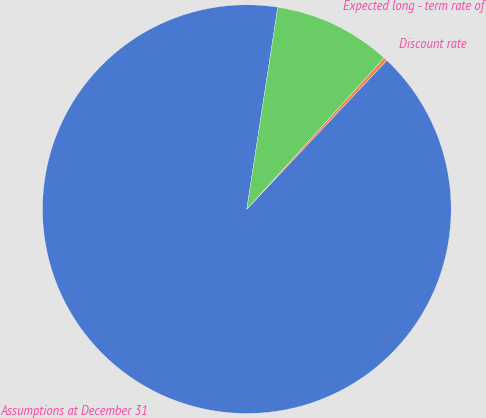Convert chart. <chart><loc_0><loc_0><loc_500><loc_500><pie_chart><fcel>Assumptions at December 31<fcel>Discount rate<fcel>Expected long - term rate of<nl><fcel>90.41%<fcel>0.29%<fcel>9.3%<nl></chart> 